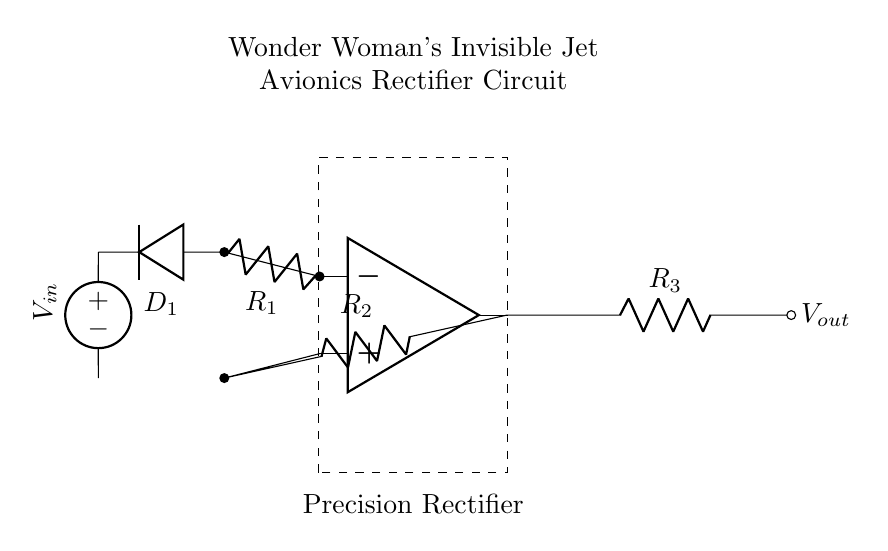What is the type of this circuit? This circuit is a precision rectifier, which is indicated in the title section of the diagram. Precision rectifiers are used to accurately rectify small input signals.
Answer: precision rectifier What component is labeled D1? D1 is identified as a diode in the circuit diagram. Typically, diodes allow current to flow in one direction and block it in the opposite direction.
Answer: diode How many resistors are in the circuit? The circuit diagram shows three resistors labeled R1, R2, and R3, as indicated next to their symbols. Counting these gives us the total number.
Answer: three What is the function of the op-amp in this circuit? The operational amplifier (op-amp) is used for amplifying the input signal in the precision rectifier setup. Its configuration allows it to provide high gain and improve the accuracy of rectification.
Answer: amplification What is the input voltage source called? The voltage source in the circuit is labeled as V-in. This indicates that it is the input to the precision rectifier circuit. This source provides the necessary voltage to be rectified.
Answer: V-in What is the output of this rectifier circuit? The output of the circuit is indicated as V-out, which is the rectified voltage signal produced after passing through the precision rectifier stage. The output represents the transformed signal.
Answer: V-out Which resistor is connected to the output of the op-amp? The resistor R2 is connected to the output of the op-amp as depicted in the circuit. It plays a role in shaping the feedback and functioning of the rectifier.
Answer: R2 